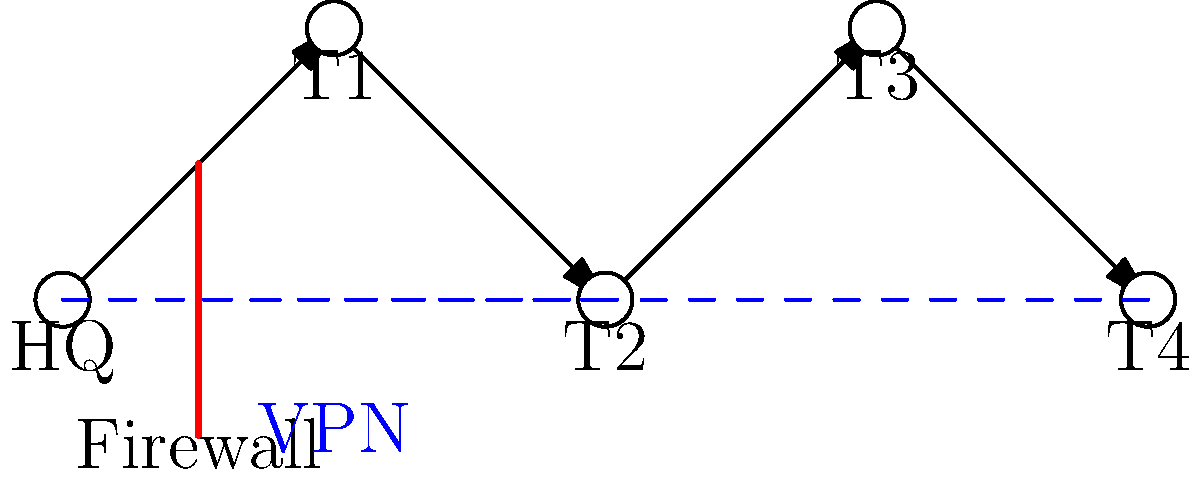As the marketing strategist for a mobile circus, you need to implement a secure network infrastructure that protects sensitive business information and customer data across multiple traveling troupes. Given the network diagram, which combination of security measures would be most effective in safeguarding data while allowing seamless communication between the headquarters (HQ) and traveling troupes (T1-T4)? To implement an effective network security strategy for a mobile circus environment, we need to consider the following steps:

1. Firewall at HQ: The diagram shows a firewall at the headquarters, which is crucial for protecting the central network from external threats.

2. VPN Tunnels: The dashed blue lines represent VPN (Virtual Private Network) connections between HQ and some troupes (T2 and T4). This indicates secure, encrypted communication channels.

3. Mobile Troupes Security: Each troupe (T1-T4) needs its own security measures, as they are mobile and connect to various networks.

4. Data Encryption: All sensitive data should be encrypted, both in transit and at rest.

5. Access Control: Implement strong authentication methods for accessing the network from mobile locations.

6. Regular Updates: Ensure all devices and software are regularly updated with the latest security patches.

7. Employee Training: Educate staff on security best practices, especially when operating in different locations.

8. Monitoring and Incident Response: Implement a system for continuous monitoring and quick response to potential security incidents.

Given these considerations, the most effective combination of security measures would be:

1. Maintain the firewall at HQ for central protection.
2. Extend VPN tunnels to all troupes (not just T2 and T4) for secure communication.
3. Implement endpoint security on all devices used by the troupes.
4. Use strong encryption for all data transmissions and storage.
5. Employ multi-factor authentication for network access.
6. Regularly update and patch all systems.
7. Conduct ongoing security awareness training for all staff.
8. Set up a centralized monitoring and incident response system.

This comprehensive approach ensures data protection while enabling efficient communication between HQ and all traveling troupes.
Answer: Firewall + VPN + Endpoint Security + Encryption + Multi-factor Authentication + Regular Updates + Training + Monitoring 